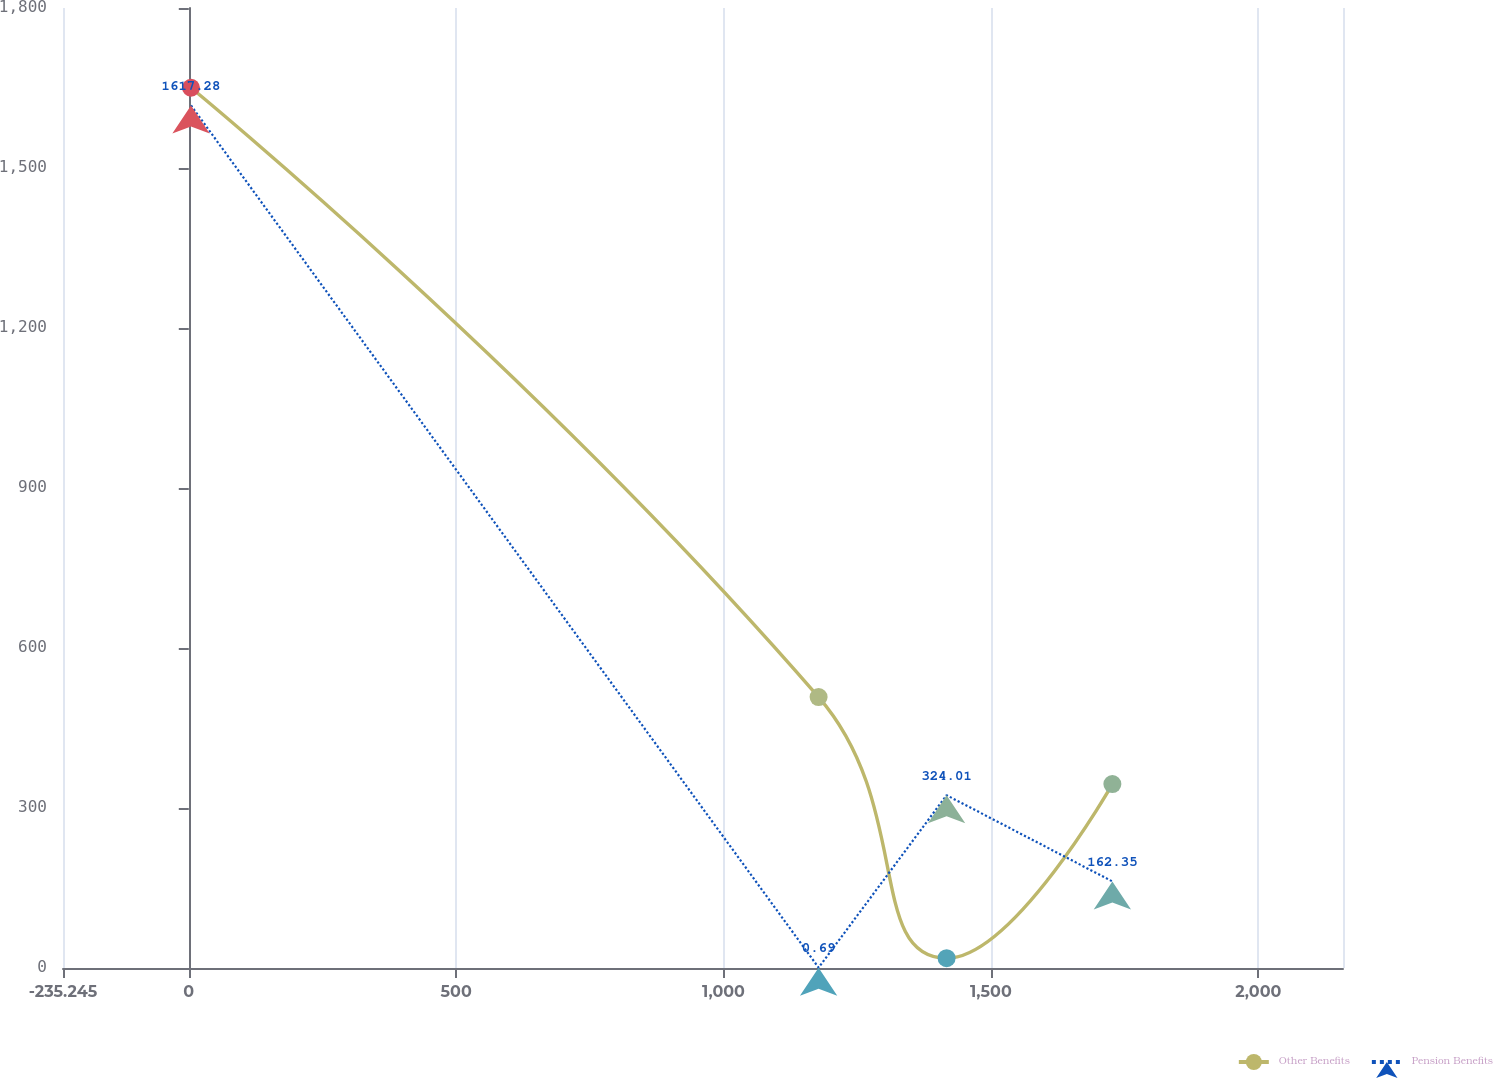Convert chart. <chart><loc_0><loc_0><loc_500><loc_500><line_chart><ecel><fcel>Other Benefits<fcel>Pension Benefits<nl><fcel>4.12<fcel>1650.45<fcel>1617.28<nl><fcel>1177.76<fcel>507.98<fcel>0.69<nl><fcel>1417.12<fcel>18.35<fcel>324.01<nl><fcel>1727.1<fcel>344.77<fcel>162.35<nl><fcel>2397.77<fcel>181.56<fcel>485.67<nl></chart> 